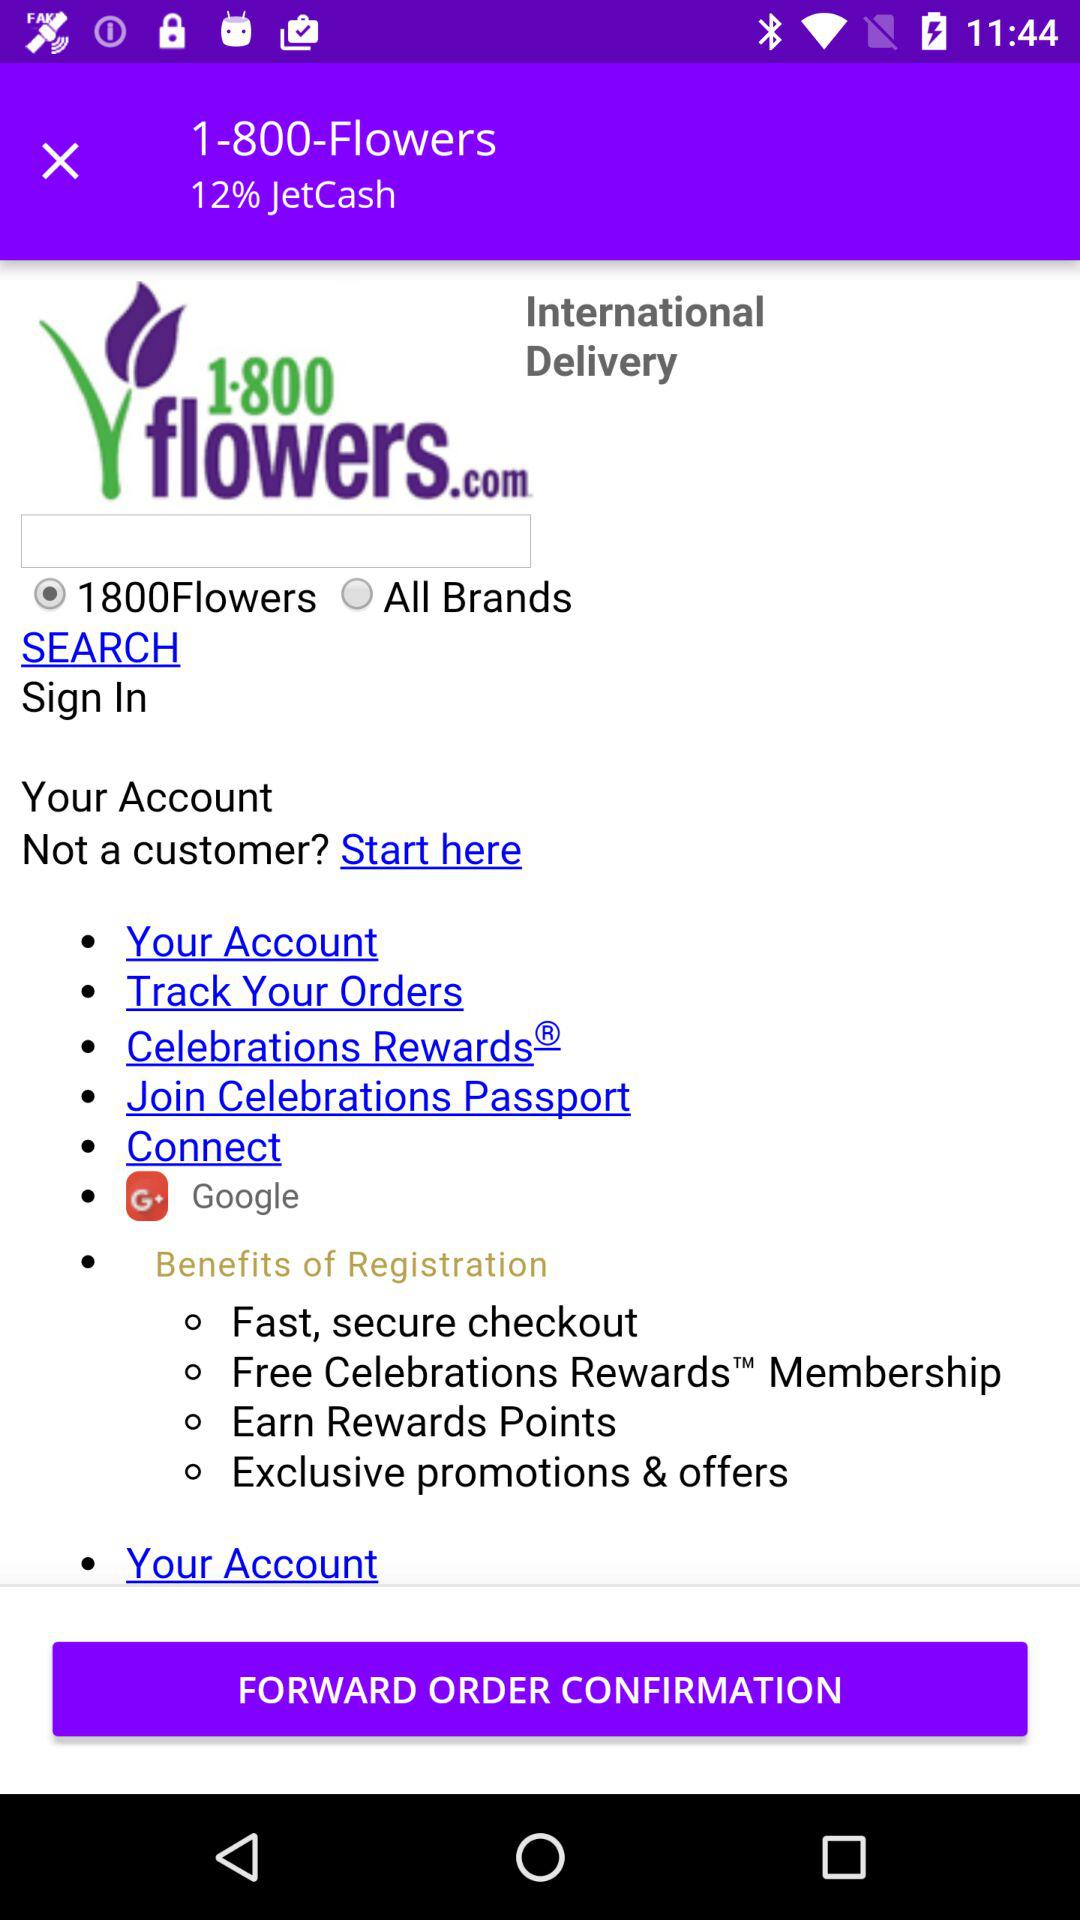What percentage of JetCash is mentioned? The percentage is 12. 